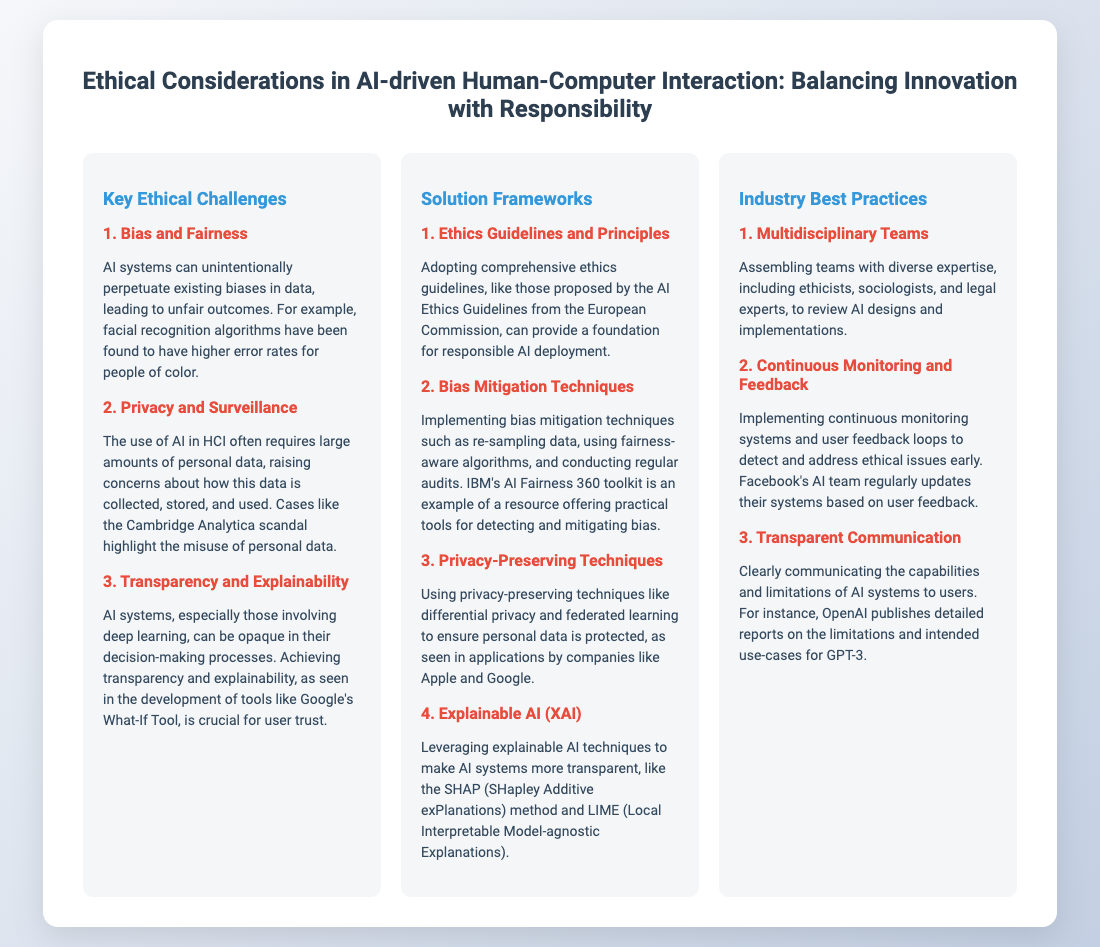What is the main title of the presentation? The main title is presented at the top of the slide, clearly indicating the focus of the content.
Answer: Ethical Considerations in AI-driven Human-Computer Interaction: Balancing Innovation with Responsibility What are the three key ethical challenges mentioned? The presentation details specific ethical challenges associated with AI, which are outlined under the key challenges section.
Answer: Bias and Fairness, Privacy and Surveillance, Transparency and Explainability Which toolkit is mentioned for bias mitigation? The document lists specific tools and frameworks for addressing bias in AI, one of which is highlighted as a practical resource.
Answer: IBM's AI Fairness 360 toolkit What principle is suggested for privacy preservation? The slide suggests techniques that help protect personal data, which is crucial for responsible AI use.
Answer: Differential privacy Which industry practice emphasizes team diversity? A best practice section highlights assembling diverse teams for ethical AI, indicating the importance of varied expertise in the design process.
Answer: Multidisciplinary Teams What method is mentioned for explainable AI? The presentation refers to specific methods that contribute to making AI systems more transparent, encapsulating their function and purpose.
Answer: SHAP (SHapley Additive exPlanations) How is feedback incorporated according to industry practices? The document emphasizes ongoing assessment methods that are crucial for improving AI design and ethical considerations over time.
Answer: Continuous Monitoring and Feedback 